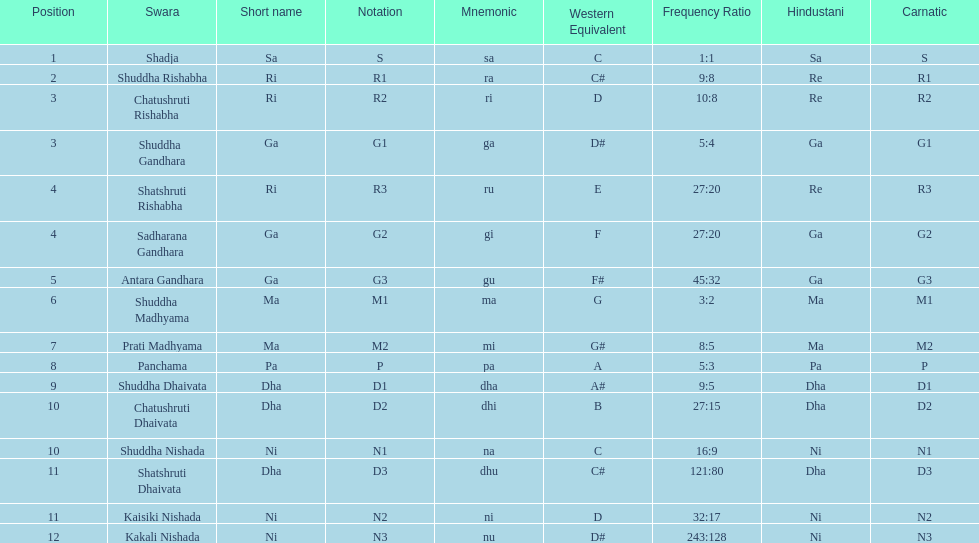On average how many of the swara have a short name that begin with d or g? 6. 